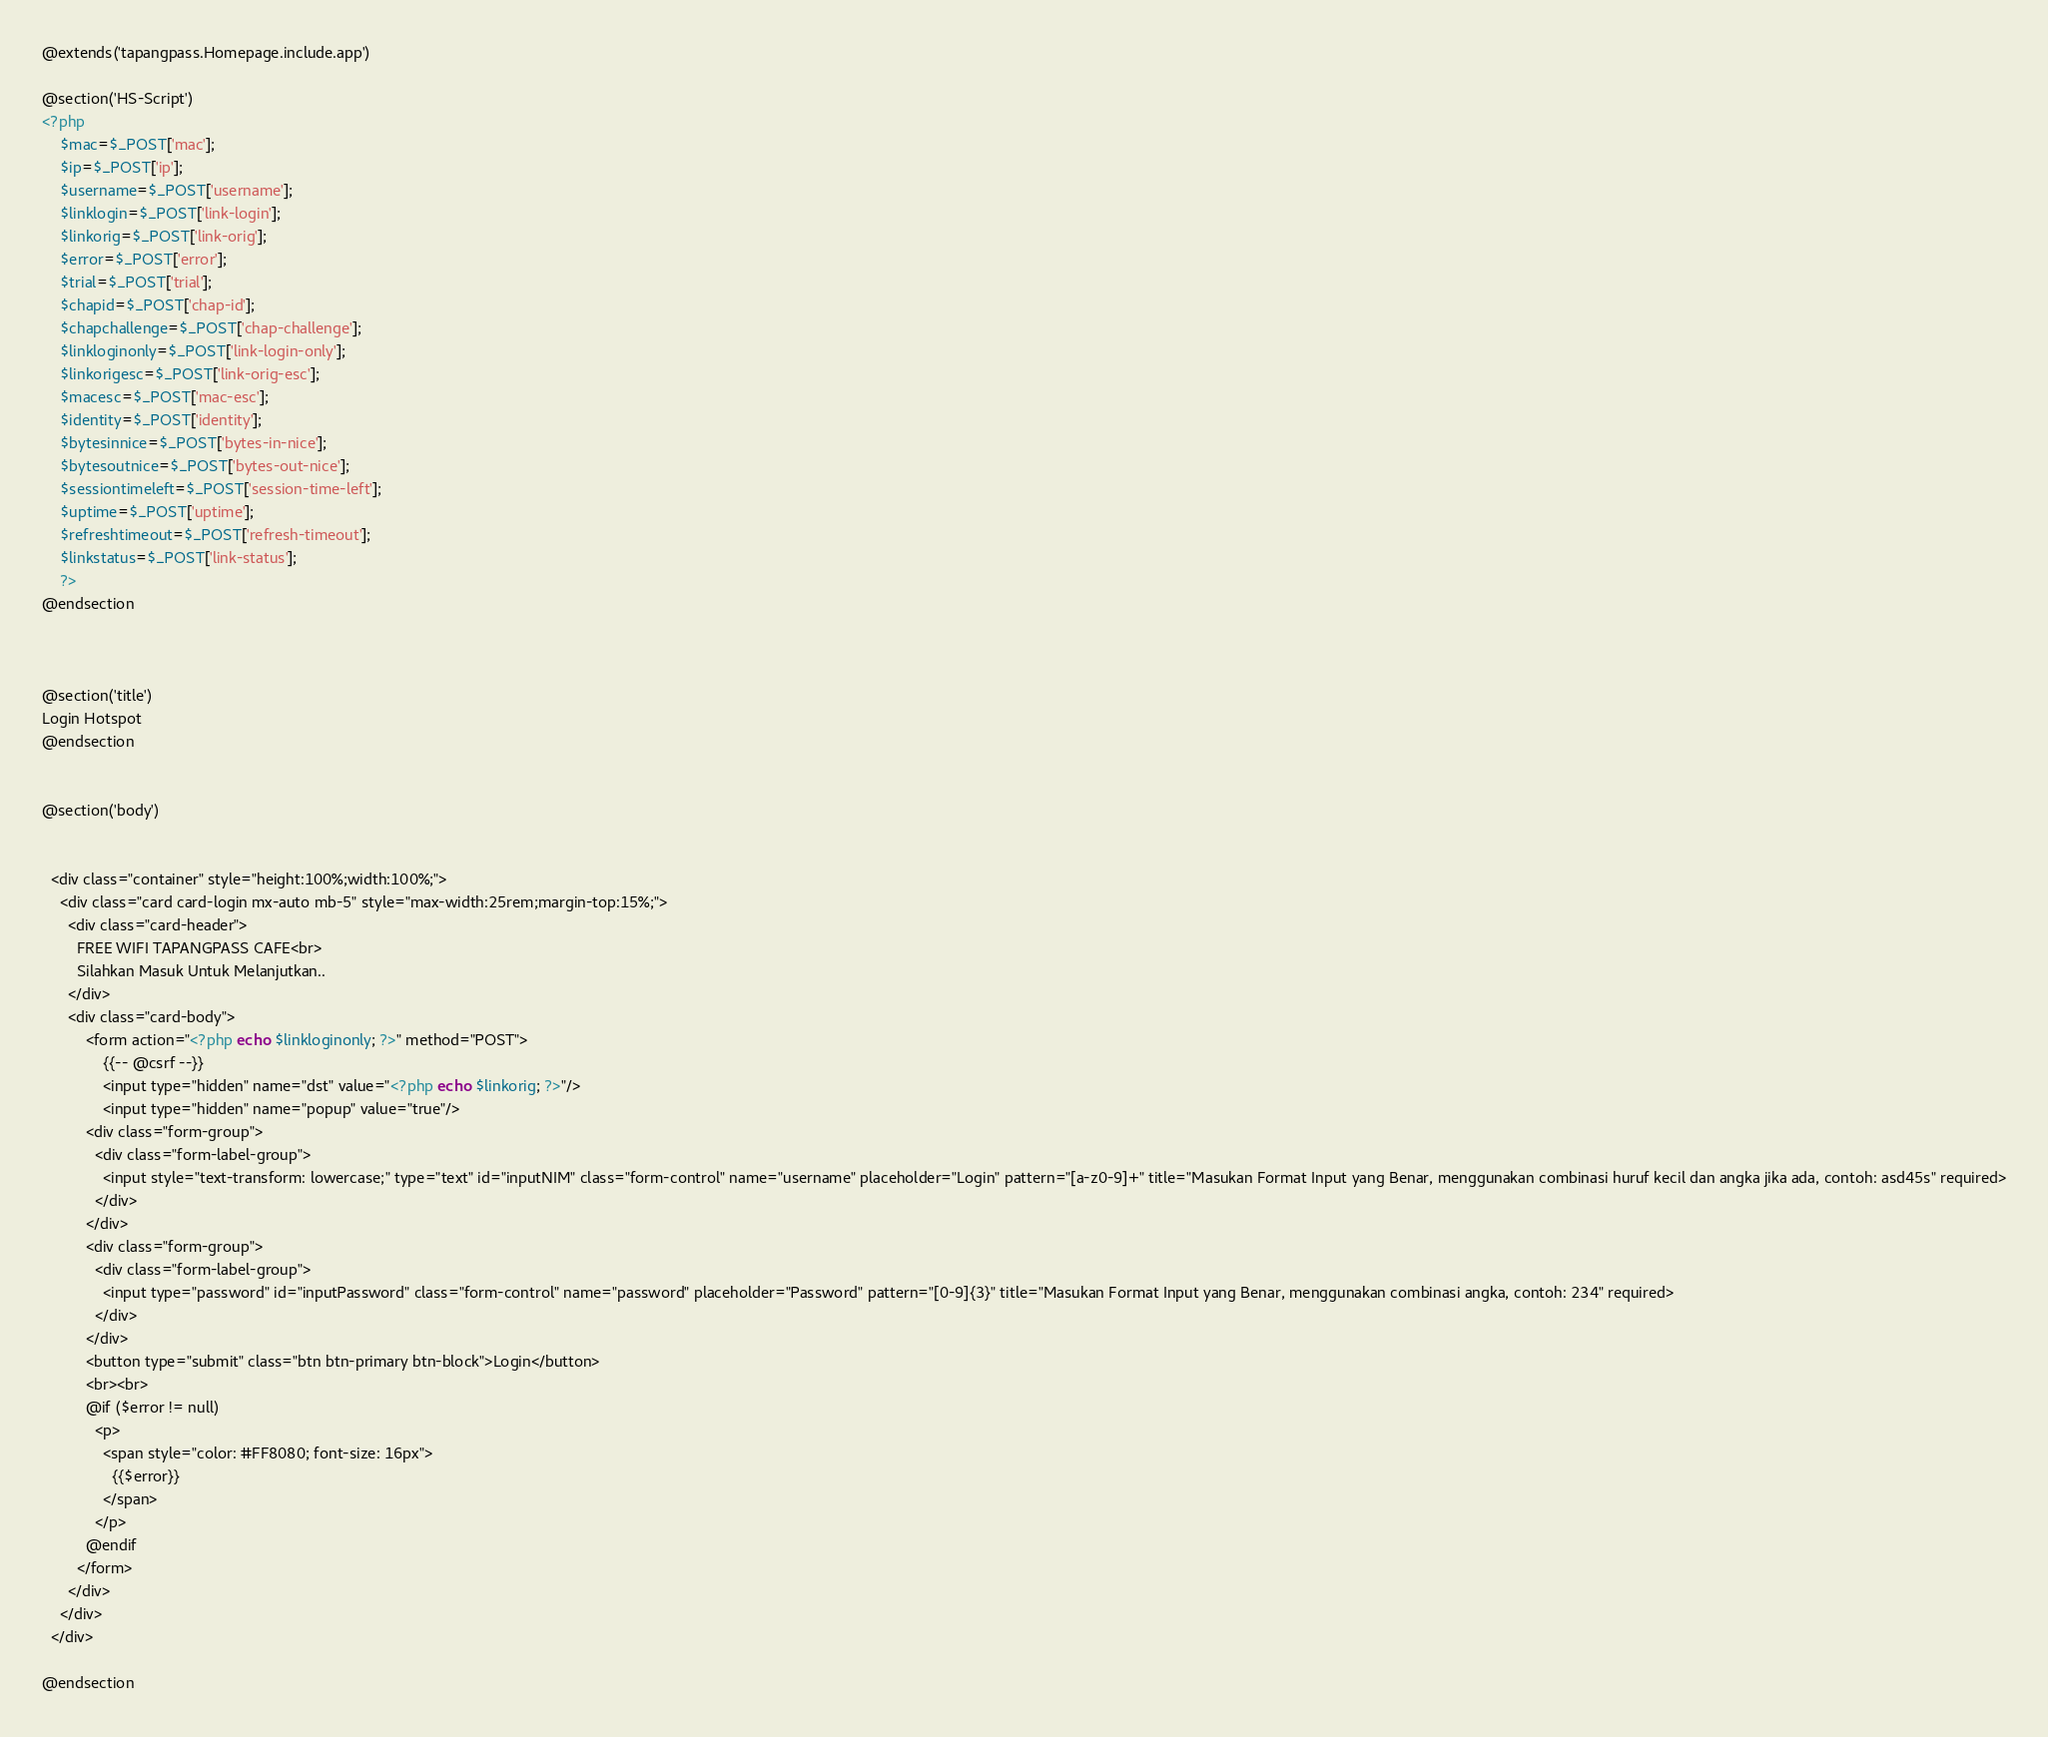Convert code to text. <code><loc_0><loc_0><loc_500><loc_500><_PHP_>@extends('tapangpass.Homepage.include.app')

@section('HS-Script')
<?php
    $mac=$_POST['mac'];
    $ip=$_POST['ip'];
    $username=$_POST['username'];
    $linklogin=$_POST['link-login'];
    $linkorig=$_POST['link-orig'];
    $error=$_POST['error'];
    $trial=$_POST['trial'];
    $chapid=$_POST['chap-id'];
    $chapchallenge=$_POST['chap-challenge'];
    $linkloginonly=$_POST['link-login-only'];
    $linkorigesc=$_POST['link-orig-esc'];
    $macesc=$_POST['mac-esc'];
    $identity=$_POST['identity'];
    $bytesinnice=$_POST['bytes-in-nice'];
    $bytesoutnice=$_POST['bytes-out-nice'];
    $sessiontimeleft=$_POST['session-time-left'];
    $uptime=$_POST['uptime'];
    $refreshtimeout=$_POST['refresh-timeout'];   
    $linkstatus=$_POST['link-status'];  
    ?>
@endsection



@section('title')
Login Hotspot
@endsection


@section('body')

    
  <div class="container" style="height:100%;width:100%;">
    <div class="card card-login mx-auto mb-5" style="max-width:25rem;margin-top:15%;">
      <div class="card-header">
        FREE WIFI TAPANGPASS CAFE<br>
        Silahkan Masuk Untuk Melanjutkan..
      </div>
      <div class="card-body">
          <form action="<?php echo $linkloginonly; ?>" method="POST">
              {{-- @csrf --}}
              <input type="hidden" name="dst" value="<?php echo $linkorig; ?>"/>
              <input type="hidden" name="popup" value="true"/>
          <div class="form-group">
            <div class="form-label-group">
              <input style="text-transform: lowercase;" type="text" id="inputNIM" class="form-control" name="username" placeholder="Login" pattern="[a-z0-9]+" title="Masukan Format Input yang Benar, menggunakan combinasi huruf kecil dan angka jika ada, contoh: asd45s" required>
            </div>
          </div>
          <div class="form-group">
            <div class="form-label-group">
              <input type="password" id="inputPassword" class="form-control" name="password" placeholder="Password" pattern="[0-9]{3}" title="Masukan Format Input yang Benar, menggunakan combinasi angka, contoh: 234" required>
            </div>
          </div>
          <button type="submit" class="btn btn-primary btn-block">Login</button>
          <br><br>
          @if ($error != null)
            <p>
              <span style="color: #FF8080; font-size: 16px">
                {{$error}}
              </span>
            </p>
          @endif
        </form>
      </div>
    </div>
  </div>

@endsection</code> 